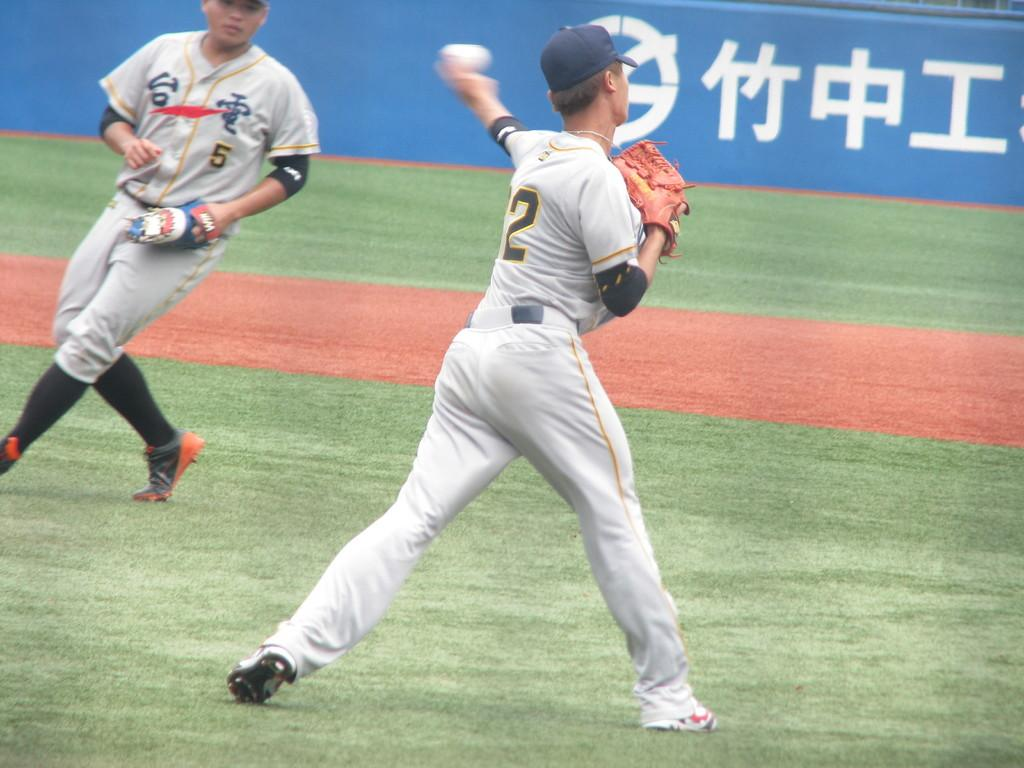<image>
Render a clear and concise summary of the photo. A baseball player with the number 5 on his jersey. 